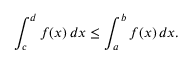<formula> <loc_0><loc_0><loc_500><loc_500>\int _ { c } ^ { d } f ( x ) \, d x \leq \int _ { a } ^ { b } f ( x ) \, d x .</formula> 